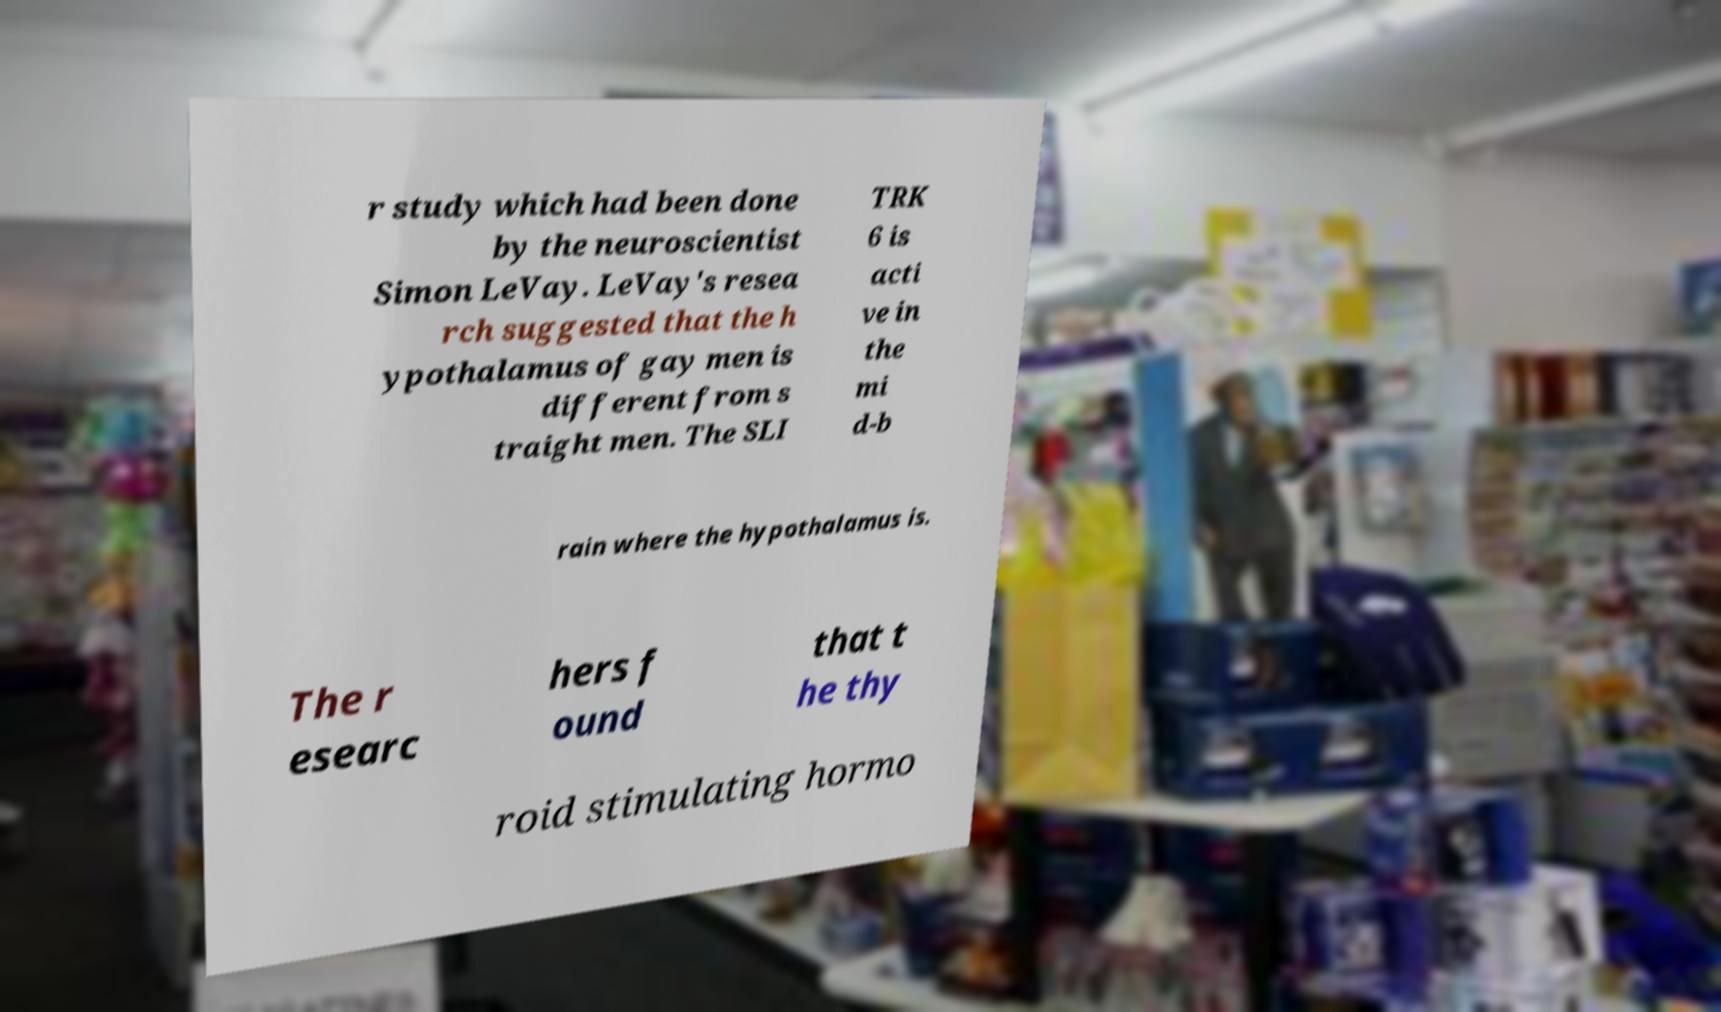Can you accurately transcribe the text from the provided image for me? r study which had been done by the neuroscientist Simon LeVay. LeVay's resea rch suggested that the h ypothalamus of gay men is different from s traight men. The SLI TRK 6 is acti ve in the mi d-b rain where the hypothalamus is. The r esearc hers f ound that t he thy roid stimulating hormo 